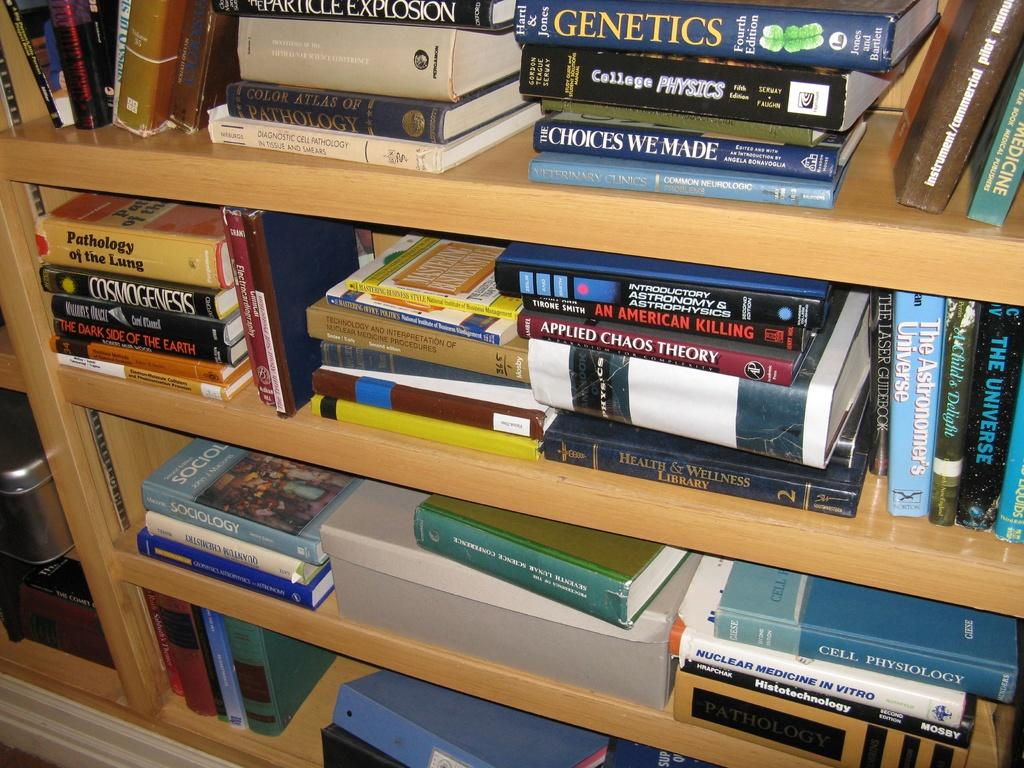<image>
Render a clear and concise summary of the photo. A book shelf full of books including a book called Genetics. 